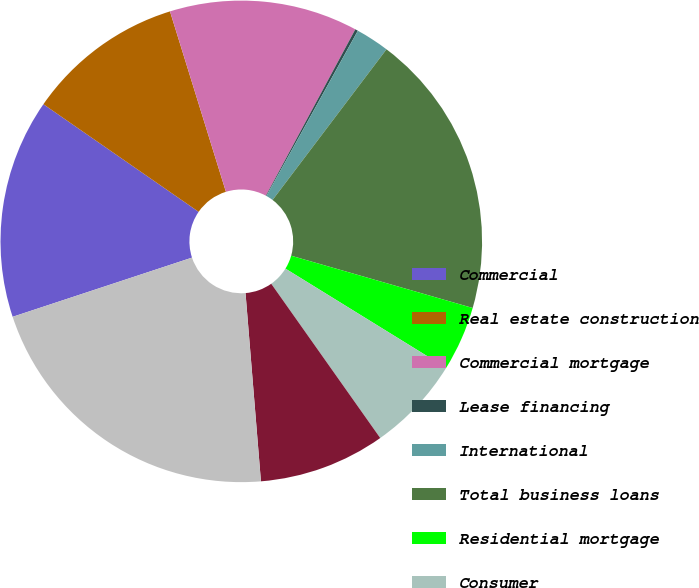Convert chart. <chart><loc_0><loc_0><loc_500><loc_500><pie_chart><fcel>Commercial<fcel>Real estate construction<fcel>Commercial mortgage<fcel>Lease financing<fcel>International<fcel>Total business loans<fcel>Residential mortgage<fcel>Consumer<fcel>Total retail loans<fcel>Total loans<nl><fcel>14.72%<fcel>10.57%<fcel>12.64%<fcel>0.19%<fcel>2.26%<fcel>19.16%<fcel>4.34%<fcel>6.41%<fcel>8.49%<fcel>21.23%<nl></chart> 